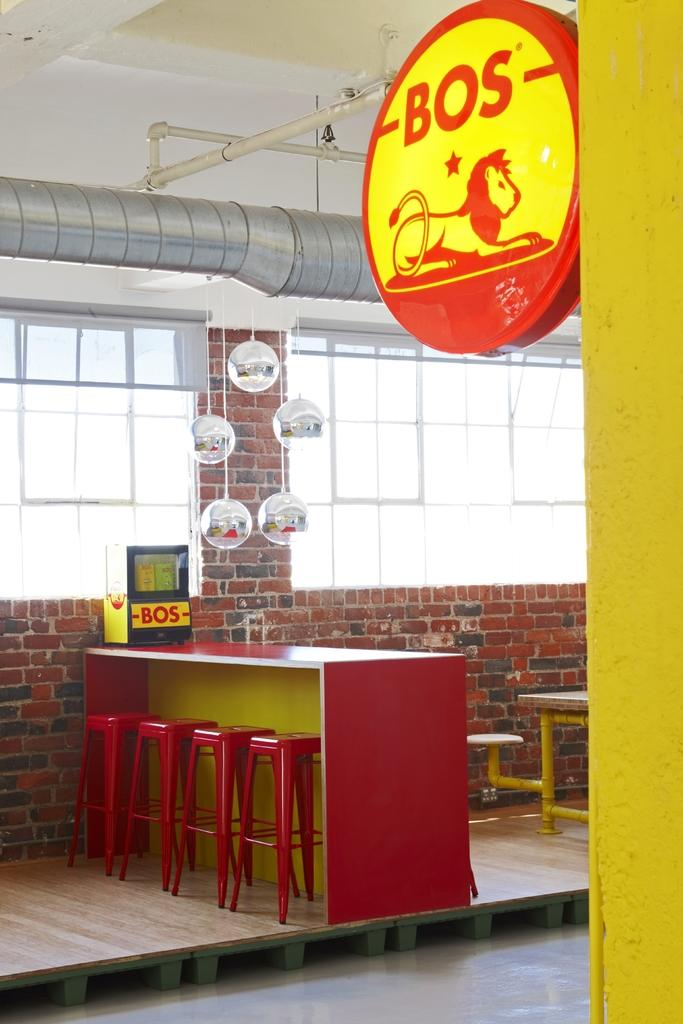What type of furniture is visible in the image? There are stools and tables in the image. What is the purpose of the board in the image? The purpose of the board in the image is not specified, but it could be used for writing or displaying information. What can be seen through the windows in the image? The view through the windows is not specified, but it is likely that they provide a view of the outdoors or another part of the room. What type of structure is visible in the image? There is a wall in the image, which suggests that the image is of an indoor space. What type of plumbing is visible in the image? There are pipes in the image, which could be part of a plumbing system or used for other purposes. Can you describe any other objects present in the image? There are other objects present in the image, but their specific purpose or appearance is not specified. How many levels can be seen in the image? There are no levels visible in the image. 